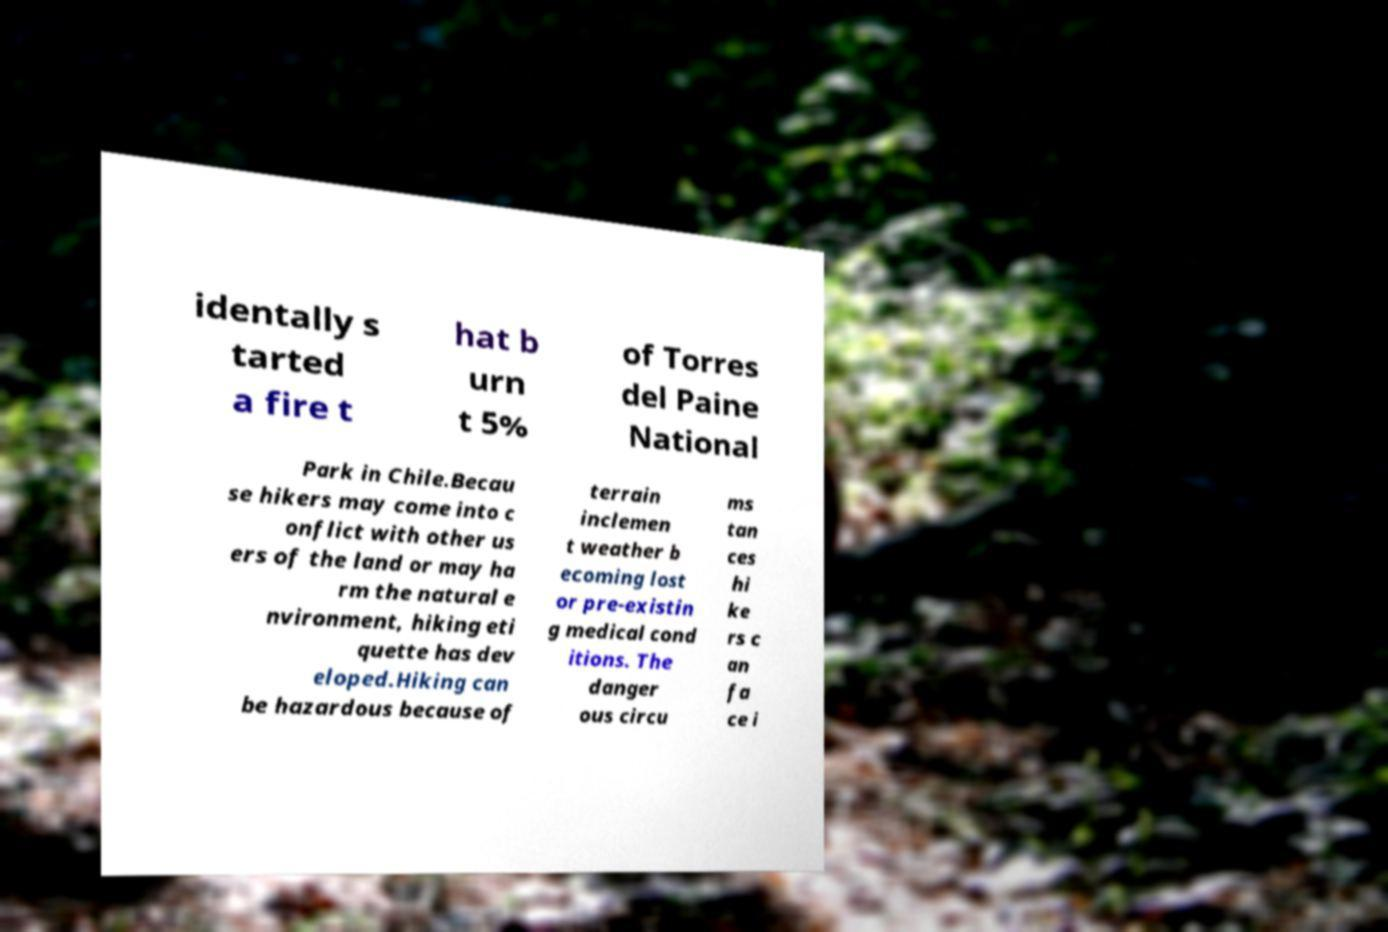Can you read and provide the text displayed in the image?This photo seems to have some interesting text. Can you extract and type it out for me? identally s tarted a fire t hat b urn t 5% of Torres del Paine National Park in Chile.Becau se hikers may come into c onflict with other us ers of the land or may ha rm the natural e nvironment, hiking eti quette has dev eloped.Hiking can be hazardous because of terrain inclemen t weather b ecoming lost or pre-existin g medical cond itions. The danger ous circu ms tan ces hi ke rs c an fa ce i 